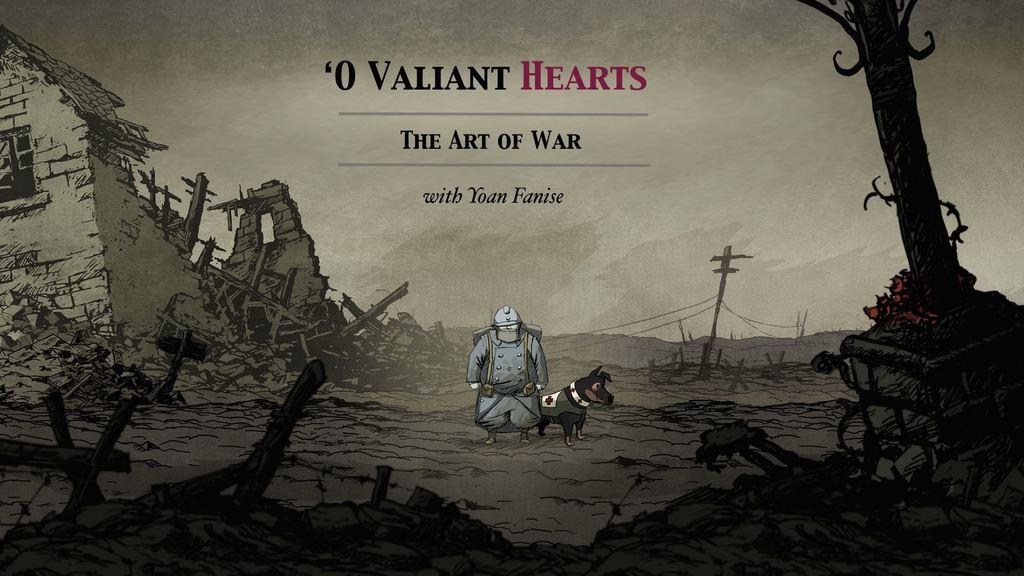What is featured on the poster in the image? There is a poster with text in the image. What type of animated images can be seen in the image? There is an animated image of a person and an animated image of a dog in the image. What material can be seen in the image? There are wooden pieces in the image. What structure is visible in the image? There is an electric pole with wires in the image. What type of pot is visible in the image? There is no pot present in the image. Can you see an owl in the image? No, there is no owl in the image. 